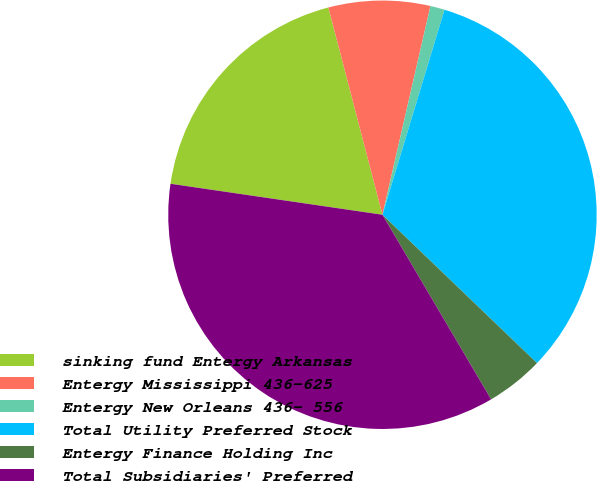<chart> <loc_0><loc_0><loc_500><loc_500><pie_chart><fcel>sinking fund Entergy Arkansas<fcel>Entergy Mississippi 436-625<fcel>Entergy New Orleans 436- 556<fcel>Total Utility Preferred Stock<fcel>Entergy Finance Holding Inc<fcel>Total Subsidiaries' Preferred<nl><fcel>18.63%<fcel>7.66%<fcel>1.08%<fcel>32.5%<fcel>4.36%<fcel>35.78%<nl></chart> 